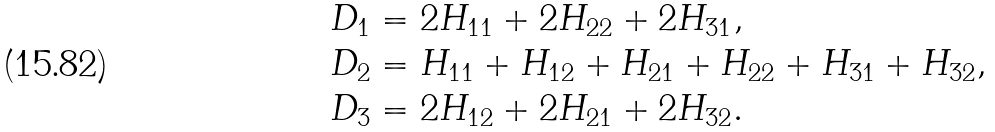Convert formula to latex. <formula><loc_0><loc_0><loc_500><loc_500>D _ { 1 } & = 2 H _ { 1 1 } + 2 H _ { 2 2 } + 2 H _ { 3 1 } , \\ D _ { 2 } & = H _ { 1 1 } + H _ { 1 2 } + H _ { 2 1 } + H _ { 2 2 } + H _ { 3 1 } + H _ { 3 2 } , \\ D _ { 3 } & = 2 H _ { 1 2 } + 2 H _ { 2 1 } + 2 H _ { 3 2 } .</formula> 